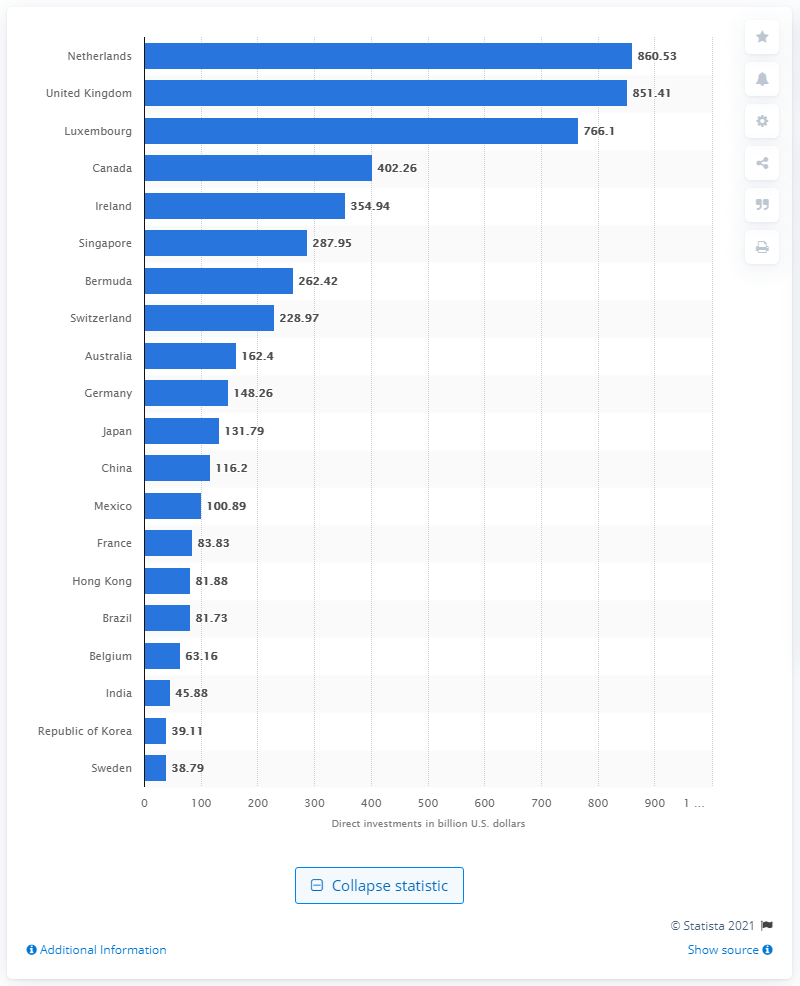Indicate a few pertinent items in this graphic. In 2019, the Netherlands received direct investment from the United States valued at 860.53... 